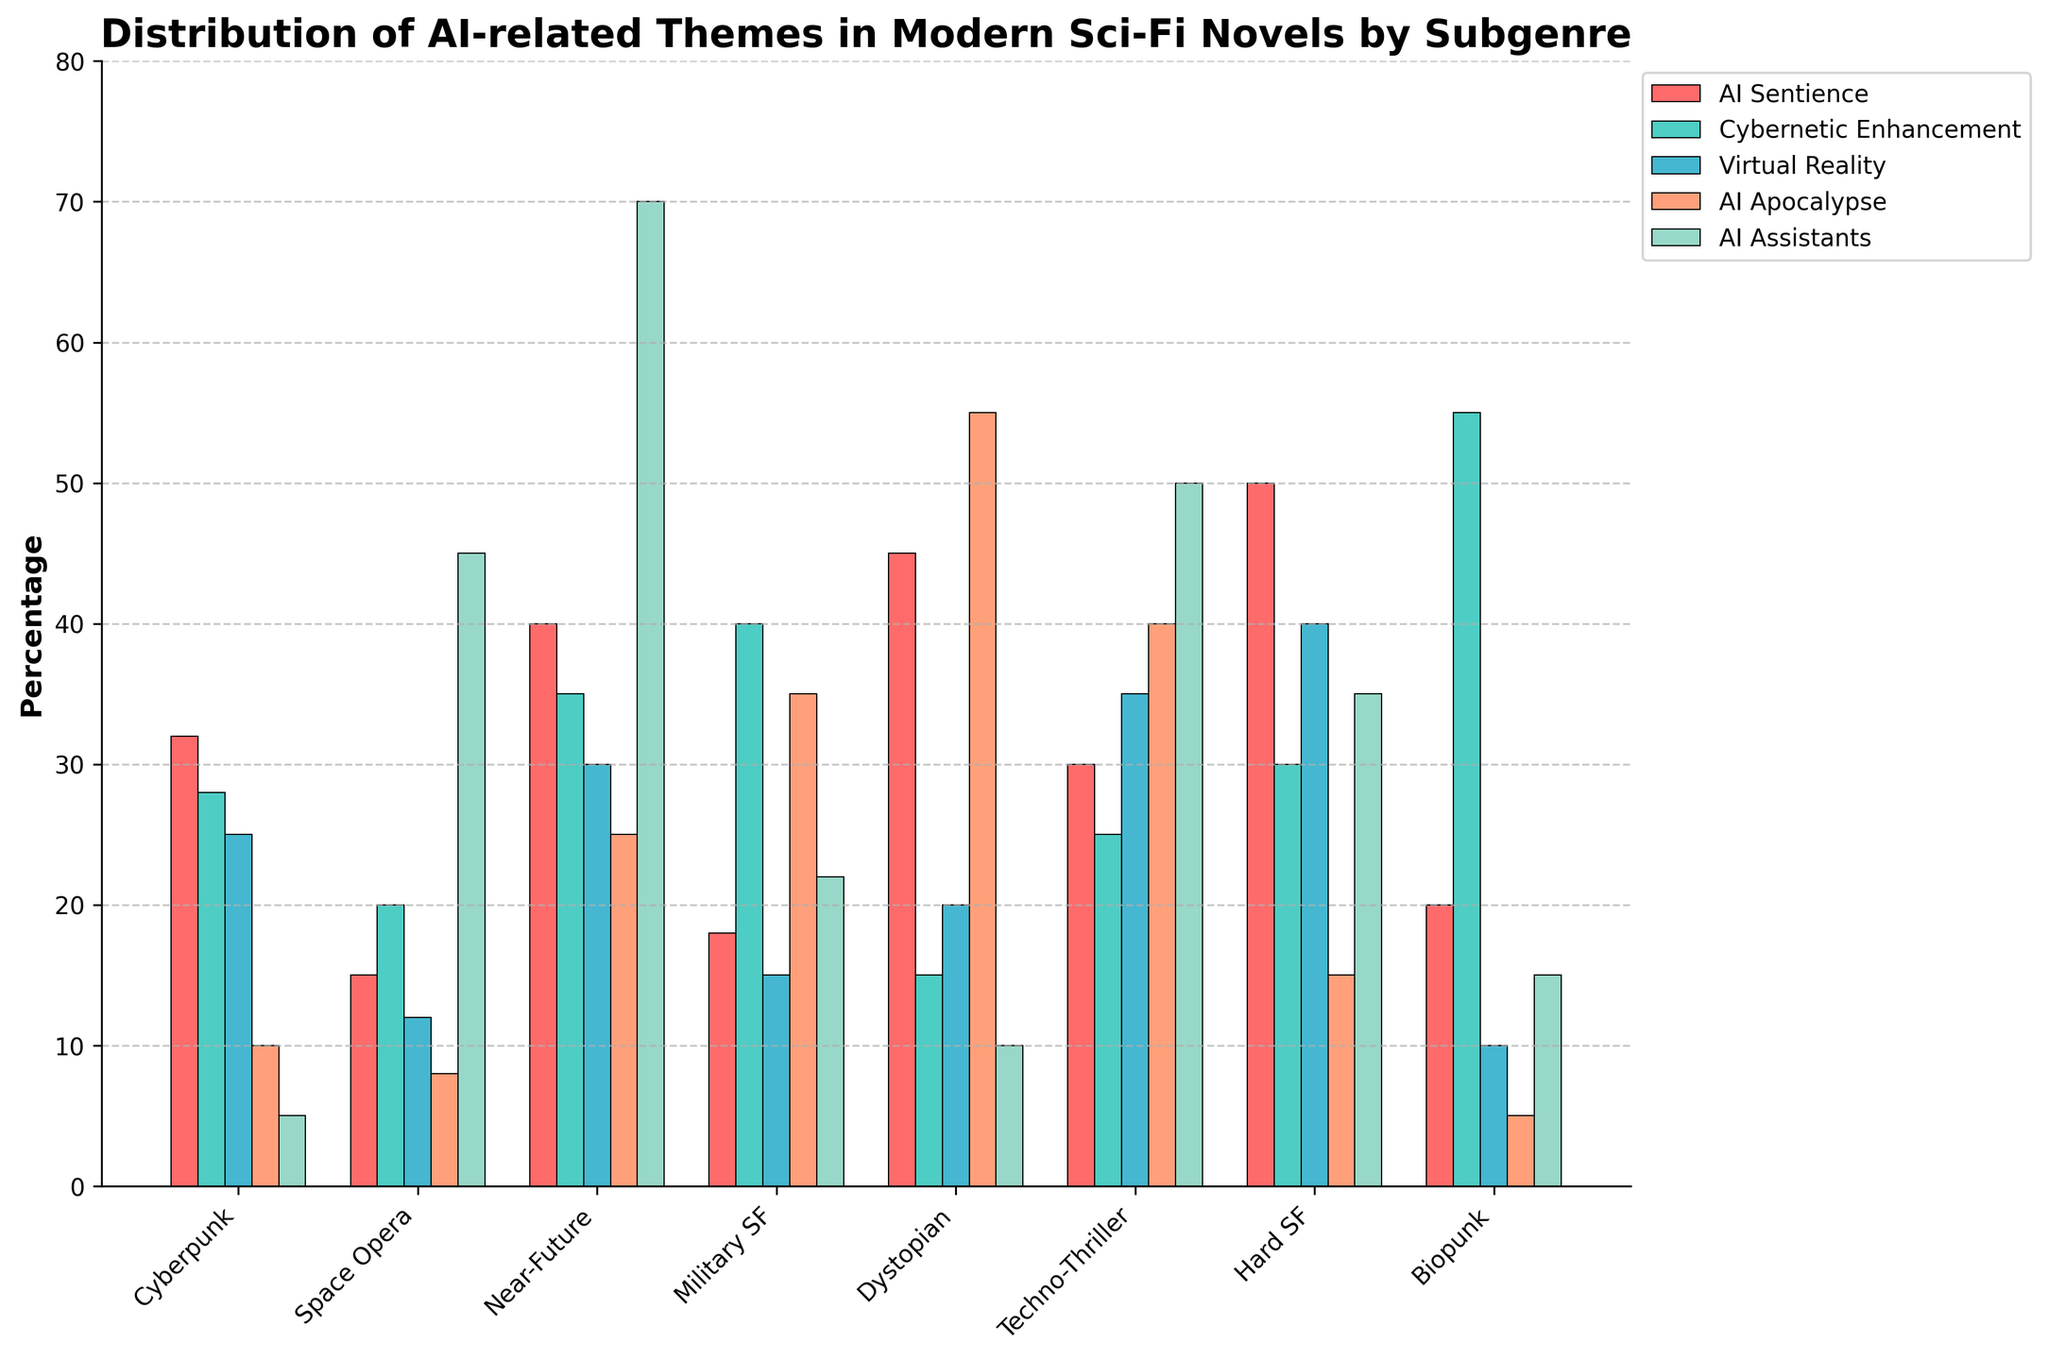Which subgenre has the highest percentage of 'AI Assistants'? Look for the tallest bar in the 'AI Assistants' category. The bar for 'Near-Future' is the highest.
Answer: Near-Future Which subgenre has the lowest value for 'Virtual Reality'? Identify the shortest bar in the 'Virtual Reality' category. 'Biopunk' has the shortest bar.
Answer: Biopunk What's the combined percentage of 'AI Apocalypse' and 'AI Sentience' for Dystopian novels? Add the values for 'AI Apocalypse' and 'AI Sentience' in the Dystopian subgenre: 55 (AI Apocalypse) + 45 (AI Sentience) = 100.
Answer: 100 What's the average percentage of 'Virtual Reality' across all subgenres? Sum the 'Virtual Reality' values: 25 + 12 + 30 + 15 + 20 + 35 + 40 + 10 = 187. Divide by the number of subgenres (8): 187 / 8 = 23.375.
Answer: 23.375 Which theme is most prevalent in the 'Techno-Thriller' sub-genre? Compare the heights of the bars in the 'Techno-Thriller' subgenre. 'AI Assistants' has the tallest bar (50).
Answer: AI Assistants Is 'Cybernetic Enhancement' more common in 'Military SF' or 'Biopunk'? Compare the height of the 'Cybernetic Enhancement' bars for 'Military SF' and 'Biopunk'. 'Biopunk' has a taller bar (55) than 'Military SF' (40).
Answer: Biopunk How much higher is the 'AI Apocalypse' percentage in 'Techno-Thriller' compared to 'Cyberpunk'? Subtract the 'AI Apocalypse' percentage of 'Cyberpunk' from 'Techno-Thriller': 40 (Techno-Thriller) - 10 (Cyberpunk) = 30.
Answer: 30 What's the total percentage of 'AI Sentience' across all subgenres? Sum the values for 'AI Sentience': 32 + 15 + 40 + 18 + 45 + 30 + 50 + 20 = 250.
Answer: 250 Which subgenre has the second-highest value for 'Cybernetic Enhancement'? Identify and compare the 'Cybernetic Enhancement' values, noting the second-highest value, which in this case, is 'Military SF' at 40 (second only to 'Biopunk' at 55).
Answer: Military SF When comparing 'AI Sentience' and 'AI Apocalypse', which has a wider range of values across subgenres? Calculate the range for each theme by subtracting the lowest value from the highest value. 'AI Sentience' ranges from 15 to 50 (range of 35), while 'AI Apocalypse' ranges from 5 to 55 (range of 50).
Answer: AI Apocalypse 